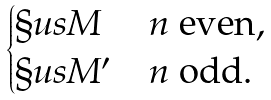<formula> <loc_0><loc_0><loc_500><loc_500>\begin{cases} \S u s M & n \ \text {even} , \\ \S u s M ^ { \prime } & n \ \text {odd} . \end{cases}</formula> 